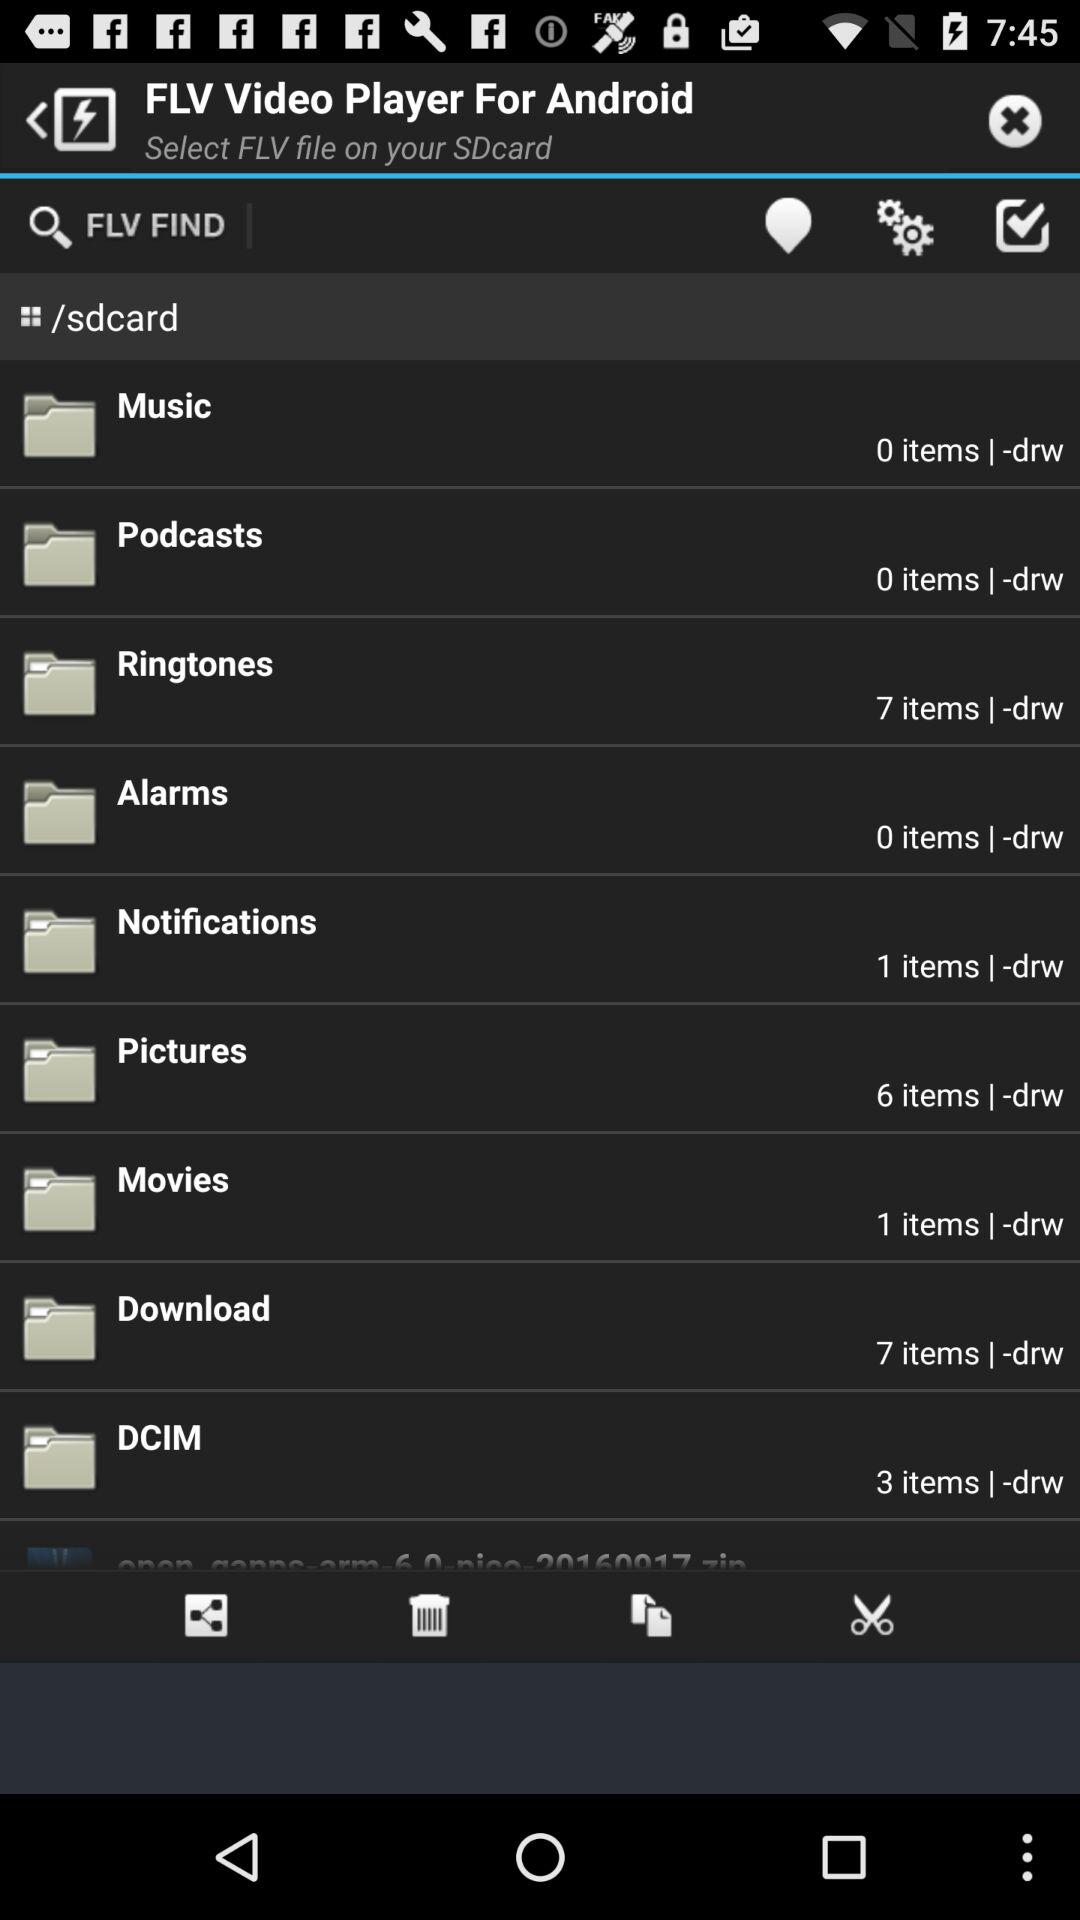How many items are in the folder named 'DCIM'?
Answer the question using a single word or phrase. 3 